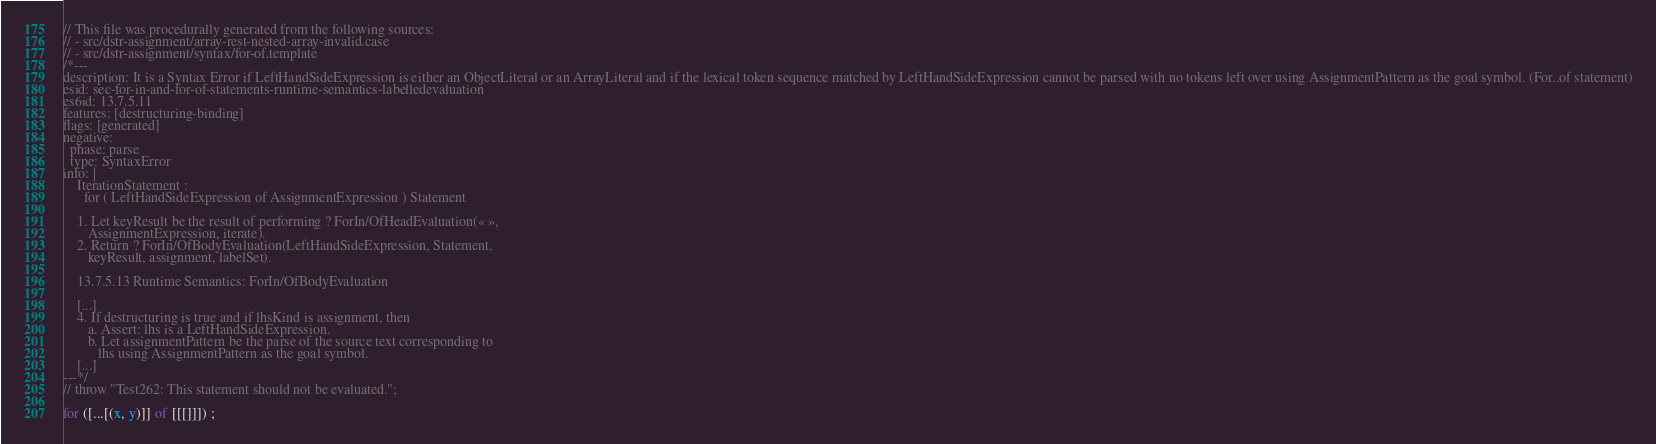Convert code to text. <code><loc_0><loc_0><loc_500><loc_500><_JavaScript_>// This file was procedurally generated from the following sources:
// - src/dstr-assignment/array-rest-nested-array-invalid.case
// - src/dstr-assignment/syntax/for-of.template
/*---
description: It is a Syntax Error if LeftHandSideExpression is either an ObjectLiteral or an ArrayLiteral and if the lexical token sequence matched by LeftHandSideExpression cannot be parsed with no tokens left over using AssignmentPattern as the goal symbol. (For..of statement)
esid: sec-for-in-and-for-of-statements-runtime-semantics-labelledevaluation
es6id: 13.7.5.11
features: [destructuring-binding]
flags: [generated]
negative:
  phase: parse
  type: SyntaxError
info: |
    IterationStatement :
      for ( LeftHandSideExpression of AssignmentExpression ) Statement

    1. Let keyResult be the result of performing ? ForIn/OfHeadEvaluation(« »,
       AssignmentExpression, iterate).
    2. Return ? ForIn/OfBodyEvaluation(LeftHandSideExpression, Statement,
       keyResult, assignment, labelSet).

    13.7.5.13 Runtime Semantics: ForIn/OfBodyEvaluation

    [...]
    4. If destructuring is true and if lhsKind is assignment, then
       a. Assert: lhs is a LeftHandSideExpression.
       b. Let assignmentPattern be the parse of the source text corresponding to
          lhs using AssignmentPattern as the goal symbol.
    [...]
---*/
// throw "Test262: This statement should not be evaluated.";

for ([...[(x, y)]] of [[[]]]) ;
</code> 